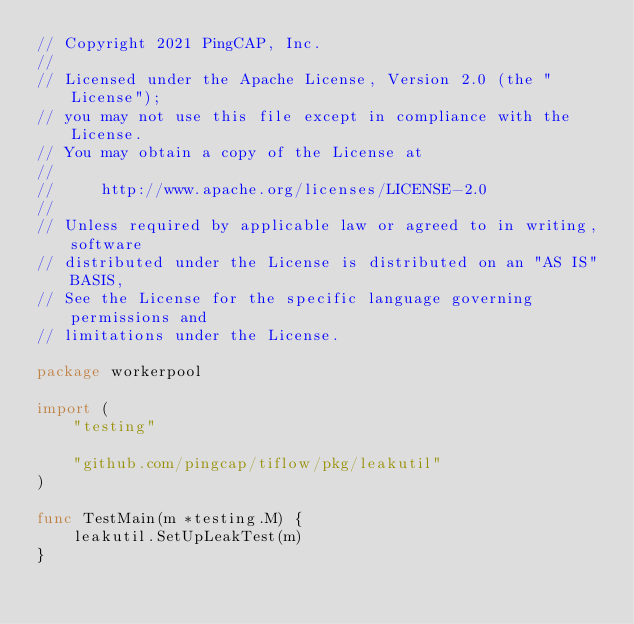Convert code to text. <code><loc_0><loc_0><loc_500><loc_500><_Go_>// Copyright 2021 PingCAP, Inc.
//
// Licensed under the Apache License, Version 2.0 (the "License");
// you may not use this file except in compliance with the License.
// You may obtain a copy of the License at
//
//     http://www.apache.org/licenses/LICENSE-2.0
//
// Unless required by applicable law or agreed to in writing, software
// distributed under the License is distributed on an "AS IS" BASIS,
// See the License for the specific language governing permissions and
// limitations under the License.

package workerpool

import (
	"testing"

	"github.com/pingcap/tiflow/pkg/leakutil"
)

func TestMain(m *testing.M) {
	leakutil.SetUpLeakTest(m)
}
</code> 